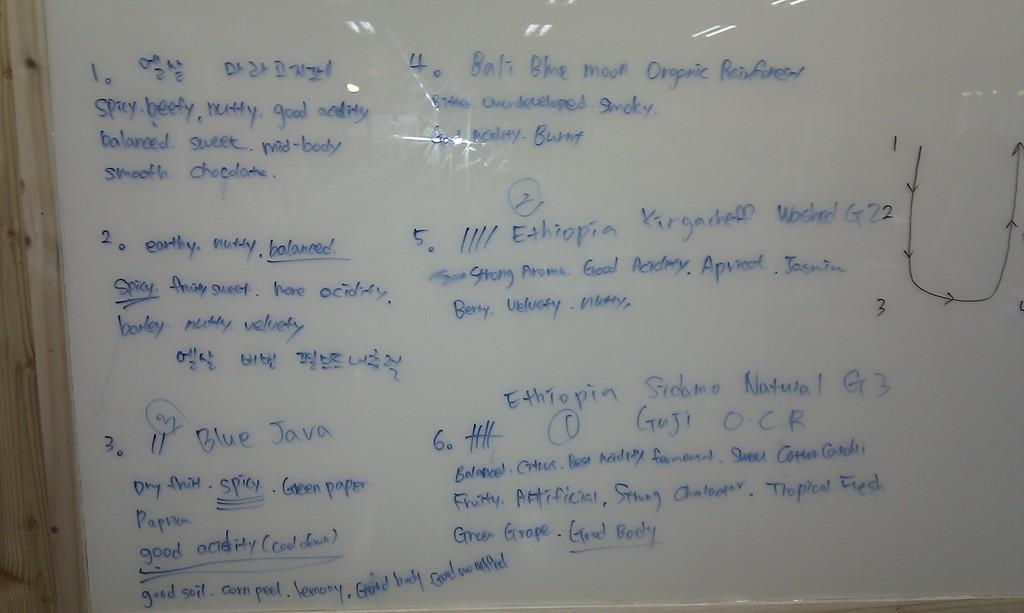<image>
Render a clear and concise summary of the photo. A whiteboard has ideas for good soil and good acidity. 